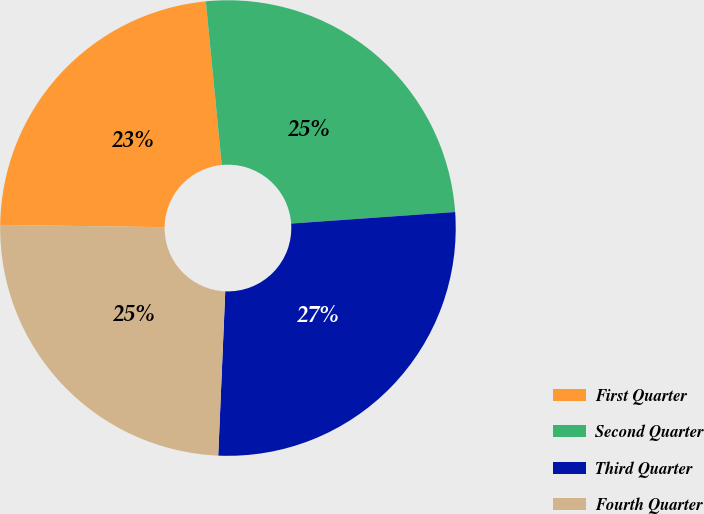Convert chart. <chart><loc_0><loc_0><loc_500><loc_500><pie_chart><fcel>First Quarter<fcel>Second Quarter<fcel>Third Quarter<fcel>Fourth Quarter<nl><fcel>23.23%<fcel>25.43%<fcel>26.8%<fcel>24.54%<nl></chart> 